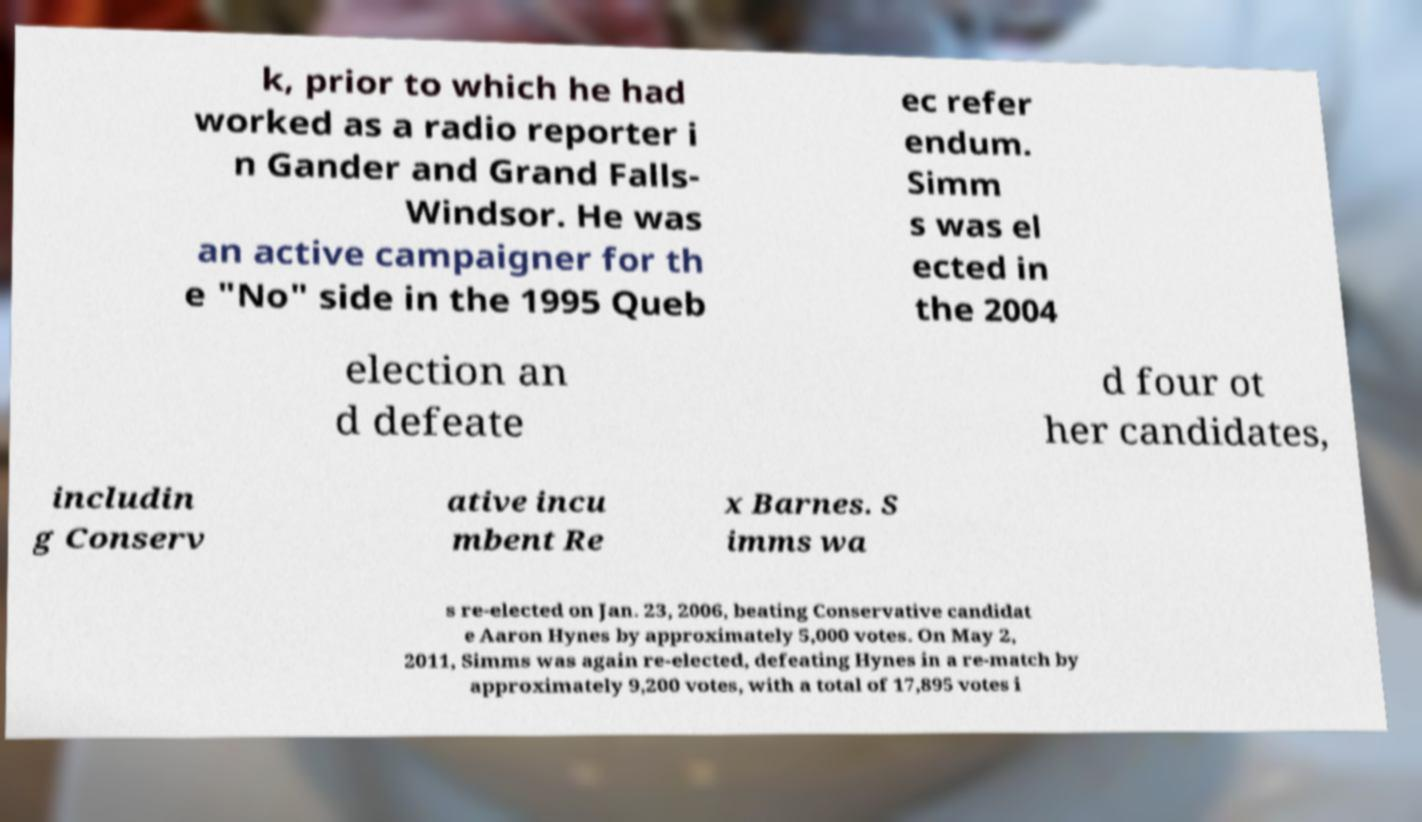Can you read and provide the text displayed in the image?This photo seems to have some interesting text. Can you extract and type it out for me? k, prior to which he had worked as a radio reporter i n Gander and Grand Falls- Windsor. He was an active campaigner for th e "No" side in the 1995 Queb ec refer endum. Simm s was el ected in the 2004 election an d defeate d four ot her candidates, includin g Conserv ative incu mbent Re x Barnes. S imms wa s re-elected on Jan. 23, 2006, beating Conservative candidat e Aaron Hynes by approximately 5,000 votes. On May 2, 2011, Simms was again re-elected, defeating Hynes in a re-match by approximately 9,200 votes, with a total of 17,895 votes i 